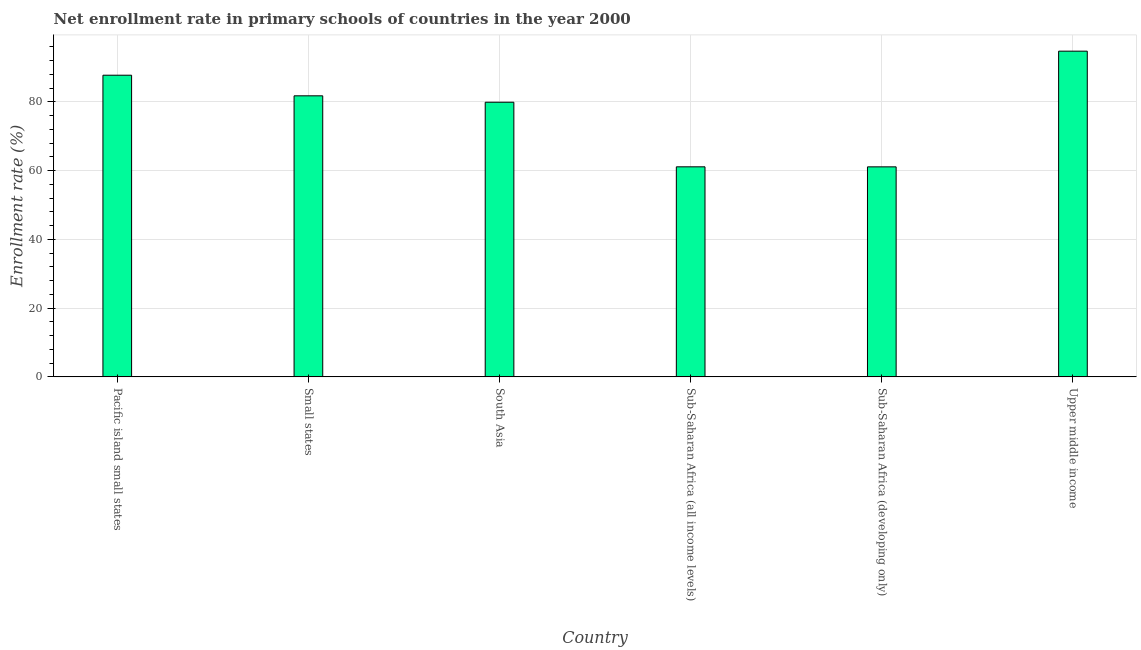Does the graph contain any zero values?
Offer a terse response. No. Does the graph contain grids?
Offer a terse response. Yes. What is the title of the graph?
Your answer should be very brief. Net enrollment rate in primary schools of countries in the year 2000. What is the label or title of the Y-axis?
Your response must be concise. Enrollment rate (%). What is the net enrollment rate in primary schools in Small states?
Give a very brief answer. 81.75. Across all countries, what is the maximum net enrollment rate in primary schools?
Provide a succinct answer. 94.74. Across all countries, what is the minimum net enrollment rate in primary schools?
Make the answer very short. 61.09. In which country was the net enrollment rate in primary schools maximum?
Your answer should be very brief. Upper middle income. In which country was the net enrollment rate in primary schools minimum?
Offer a very short reply. Sub-Saharan Africa (developing only). What is the sum of the net enrollment rate in primary schools?
Provide a short and direct response. 466.32. What is the difference between the net enrollment rate in primary schools in South Asia and Sub-Saharan Africa (developing only)?
Your answer should be very brief. 18.8. What is the average net enrollment rate in primary schools per country?
Your answer should be very brief. 77.72. What is the median net enrollment rate in primary schools?
Provide a short and direct response. 80.82. In how many countries, is the net enrollment rate in primary schools greater than 72 %?
Make the answer very short. 4. Is the difference between the net enrollment rate in primary schools in Sub-Saharan Africa (all income levels) and Sub-Saharan Africa (developing only) greater than the difference between any two countries?
Make the answer very short. No. What is the difference between the highest and the second highest net enrollment rate in primary schools?
Your answer should be compact. 7. What is the difference between the highest and the lowest net enrollment rate in primary schools?
Provide a short and direct response. 33.65. How many bars are there?
Offer a very short reply. 6. Are all the bars in the graph horizontal?
Keep it short and to the point. No. How many countries are there in the graph?
Give a very brief answer. 6. Are the values on the major ticks of Y-axis written in scientific E-notation?
Give a very brief answer. No. What is the Enrollment rate (%) of Pacific island small states?
Your response must be concise. 87.75. What is the Enrollment rate (%) of Small states?
Offer a very short reply. 81.75. What is the Enrollment rate (%) in South Asia?
Provide a short and direct response. 79.89. What is the Enrollment rate (%) in Sub-Saharan Africa (all income levels)?
Give a very brief answer. 61.1. What is the Enrollment rate (%) in Sub-Saharan Africa (developing only)?
Keep it short and to the point. 61.09. What is the Enrollment rate (%) of Upper middle income?
Provide a short and direct response. 94.74. What is the difference between the Enrollment rate (%) in Pacific island small states and Small states?
Ensure brevity in your answer.  5.99. What is the difference between the Enrollment rate (%) in Pacific island small states and South Asia?
Your answer should be very brief. 7.86. What is the difference between the Enrollment rate (%) in Pacific island small states and Sub-Saharan Africa (all income levels)?
Your answer should be very brief. 26.65. What is the difference between the Enrollment rate (%) in Pacific island small states and Sub-Saharan Africa (developing only)?
Your answer should be very brief. 26.65. What is the difference between the Enrollment rate (%) in Pacific island small states and Upper middle income?
Keep it short and to the point. -7. What is the difference between the Enrollment rate (%) in Small states and South Asia?
Provide a short and direct response. 1.86. What is the difference between the Enrollment rate (%) in Small states and Sub-Saharan Africa (all income levels)?
Provide a succinct answer. 20.65. What is the difference between the Enrollment rate (%) in Small states and Sub-Saharan Africa (developing only)?
Ensure brevity in your answer.  20.66. What is the difference between the Enrollment rate (%) in Small states and Upper middle income?
Offer a terse response. -12.99. What is the difference between the Enrollment rate (%) in South Asia and Sub-Saharan Africa (all income levels)?
Give a very brief answer. 18.79. What is the difference between the Enrollment rate (%) in South Asia and Sub-Saharan Africa (developing only)?
Provide a succinct answer. 18.8. What is the difference between the Enrollment rate (%) in South Asia and Upper middle income?
Keep it short and to the point. -14.85. What is the difference between the Enrollment rate (%) in Sub-Saharan Africa (all income levels) and Sub-Saharan Africa (developing only)?
Your answer should be compact. 0.01. What is the difference between the Enrollment rate (%) in Sub-Saharan Africa (all income levels) and Upper middle income?
Provide a succinct answer. -33.64. What is the difference between the Enrollment rate (%) in Sub-Saharan Africa (developing only) and Upper middle income?
Your response must be concise. -33.65. What is the ratio of the Enrollment rate (%) in Pacific island small states to that in Small states?
Make the answer very short. 1.07. What is the ratio of the Enrollment rate (%) in Pacific island small states to that in South Asia?
Offer a very short reply. 1.1. What is the ratio of the Enrollment rate (%) in Pacific island small states to that in Sub-Saharan Africa (all income levels)?
Keep it short and to the point. 1.44. What is the ratio of the Enrollment rate (%) in Pacific island small states to that in Sub-Saharan Africa (developing only)?
Make the answer very short. 1.44. What is the ratio of the Enrollment rate (%) in Pacific island small states to that in Upper middle income?
Provide a short and direct response. 0.93. What is the ratio of the Enrollment rate (%) in Small states to that in Sub-Saharan Africa (all income levels)?
Ensure brevity in your answer.  1.34. What is the ratio of the Enrollment rate (%) in Small states to that in Sub-Saharan Africa (developing only)?
Give a very brief answer. 1.34. What is the ratio of the Enrollment rate (%) in Small states to that in Upper middle income?
Offer a terse response. 0.86. What is the ratio of the Enrollment rate (%) in South Asia to that in Sub-Saharan Africa (all income levels)?
Make the answer very short. 1.31. What is the ratio of the Enrollment rate (%) in South Asia to that in Sub-Saharan Africa (developing only)?
Ensure brevity in your answer.  1.31. What is the ratio of the Enrollment rate (%) in South Asia to that in Upper middle income?
Your answer should be very brief. 0.84. What is the ratio of the Enrollment rate (%) in Sub-Saharan Africa (all income levels) to that in Sub-Saharan Africa (developing only)?
Make the answer very short. 1. What is the ratio of the Enrollment rate (%) in Sub-Saharan Africa (all income levels) to that in Upper middle income?
Offer a very short reply. 0.65. What is the ratio of the Enrollment rate (%) in Sub-Saharan Africa (developing only) to that in Upper middle income?
Give a very brief answer. 0.65. 